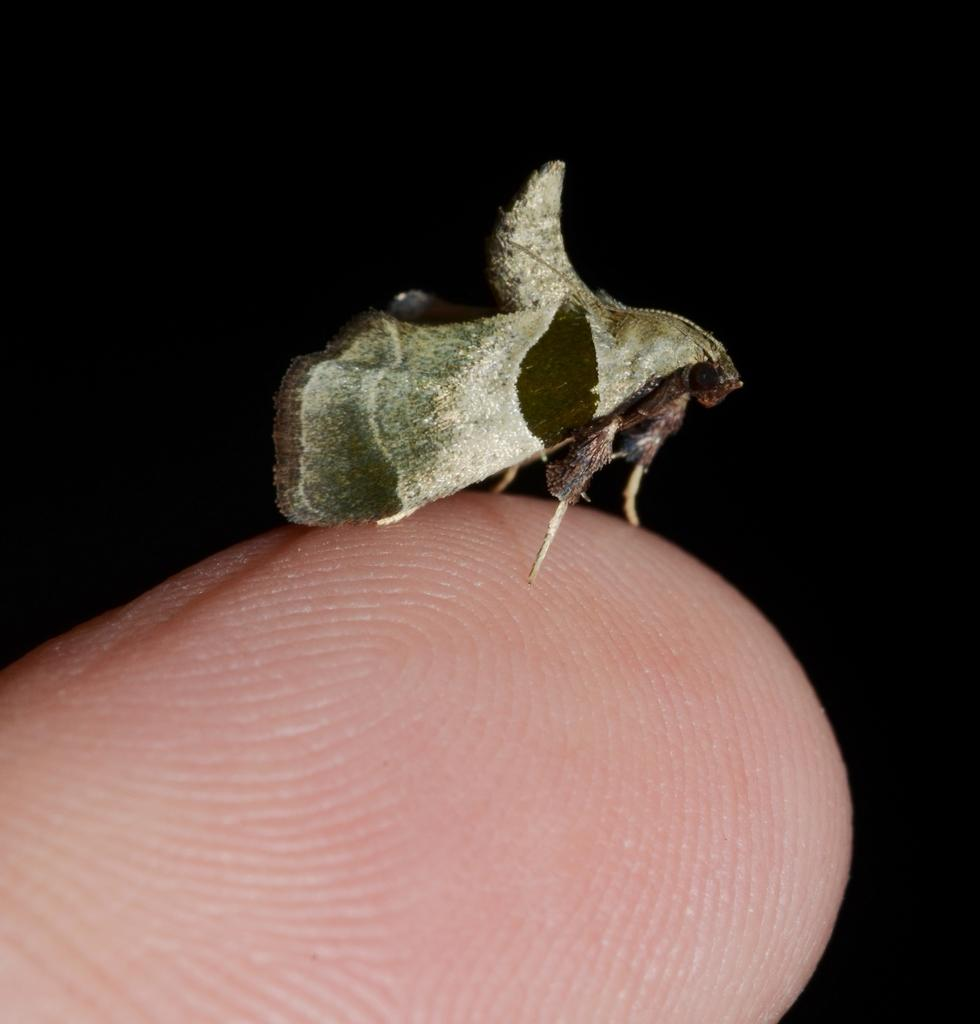What is the main subject of the image? The main subject of the image is a person's finger. Is there anything on the finger in the image? Yes, there is an insect on the finger. What can be seen in the background of the image? The background of the image is dark. How many balls are visible in the image? There are no balls present in the image. Is the person coughing in the image? There is no indication of the person coughing in the image. 